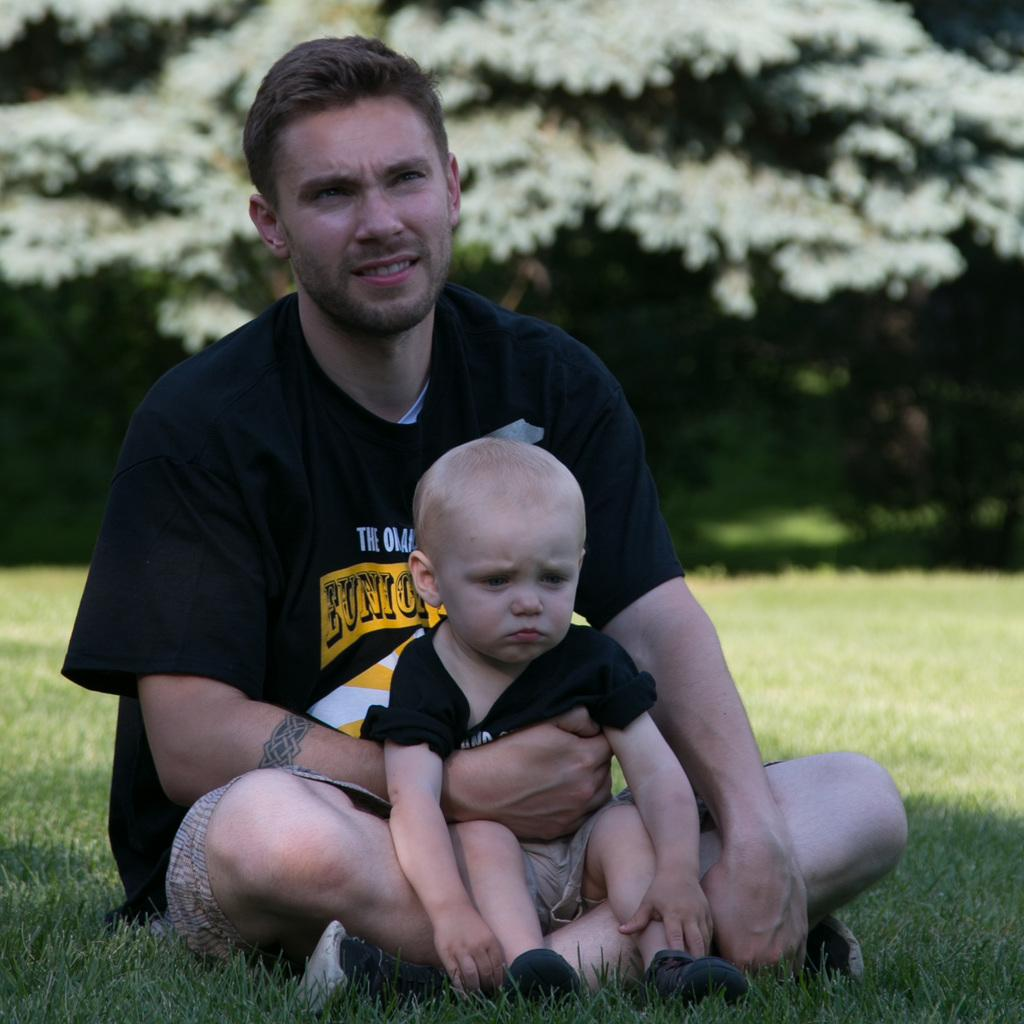What is the man in the image doing? The man is sitting on the grass in the image. Who is with the man in the image? A child is sitting on the man's lap. What is the man wearing in the image? The man is wearing a black t-shirt. What can be seen in the background of the image? There are trees visible in the background of the image. How many sticks are being used by the women in the image? There are no women or sticks present in the image. 